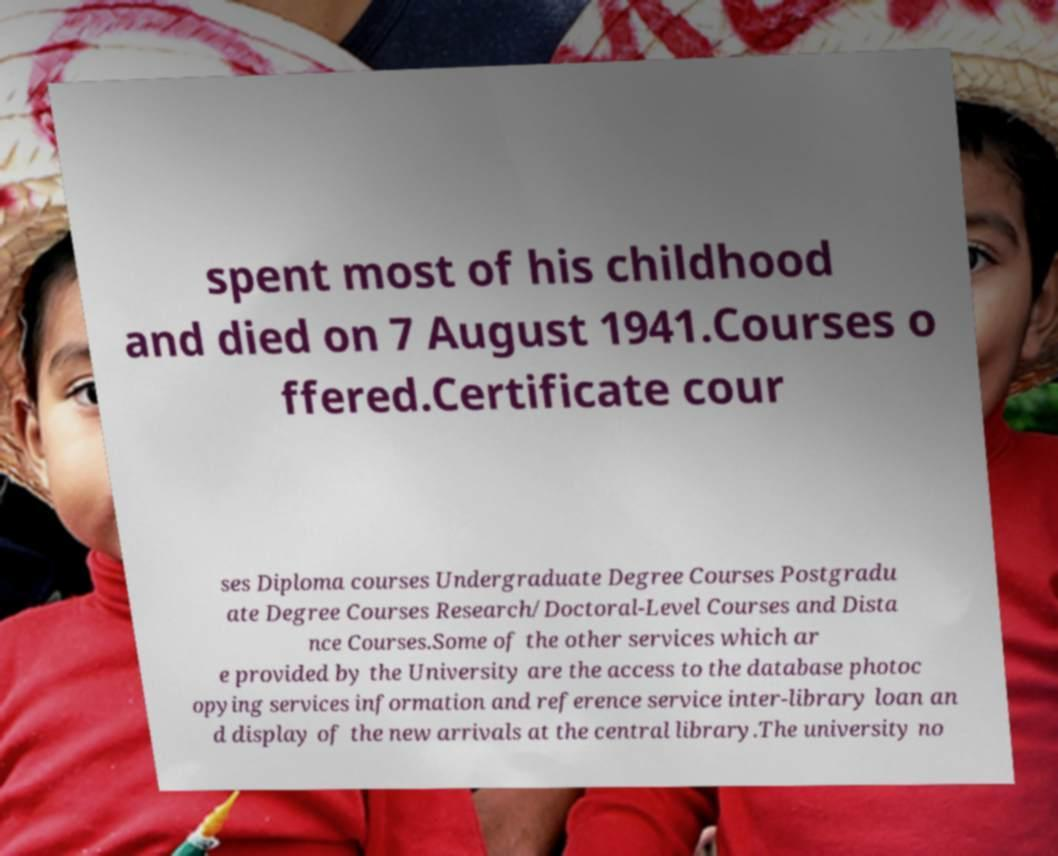Can you accurately transcribe the text from the provided image for me? spent most of his childhood and died on 7 August 1941.Courses o ffered.Certificate cour ses Diploma courses Undergraduate Degree Courses Postgradu ate Degree Courses Research/Doctoral-Level Courses and Dista nce Courses.Some of the other services which ar e provided by the University are the access to the database photoc opying services information and reference service inter-library loan an d display of the new arrivals at the central library.The university no 